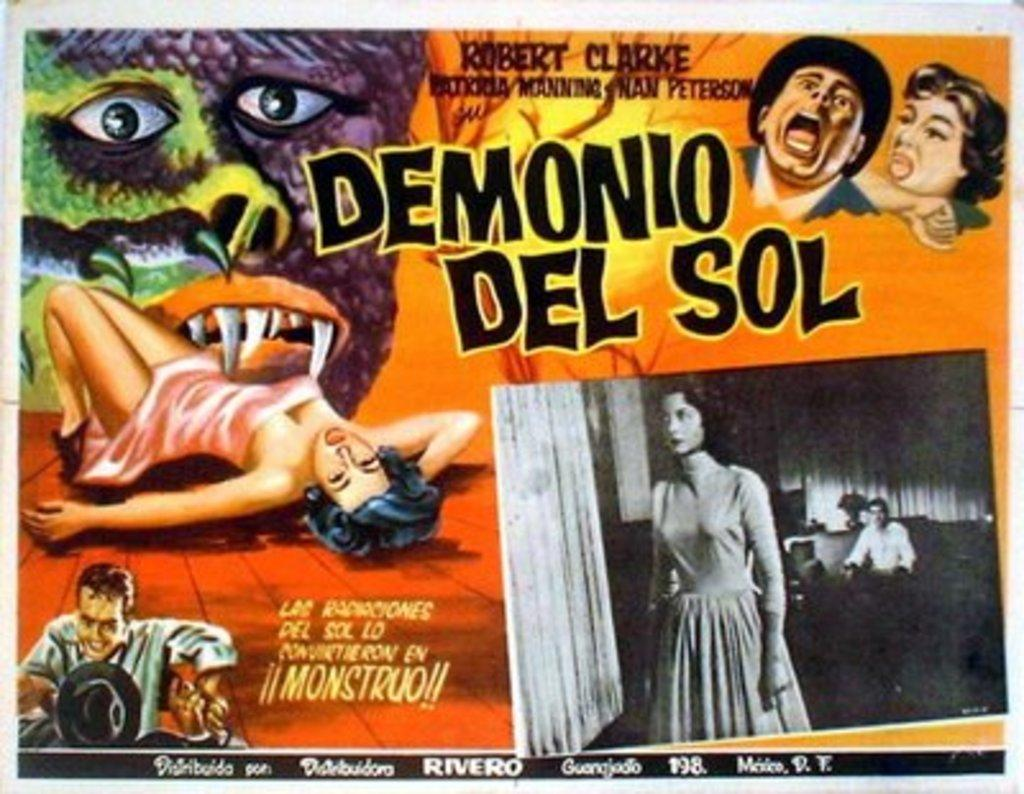<image>
Share a concise interpretation of the image provided. An ad for Demonio del Sol shows people screaming and a monster. 